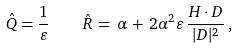<formula> <loc_0><loc_0><loc_500><loc_500>\hat { Q } = \frac { 1 } { \varepsilon } \, \quad \hat { R } \, = \, \alpha \, + \, 2 \alpha ^ { 2 } \varepsilon \, \frac { { H } \cdot { D } } { | D | ^ { 2 } } \, ,</formula> 